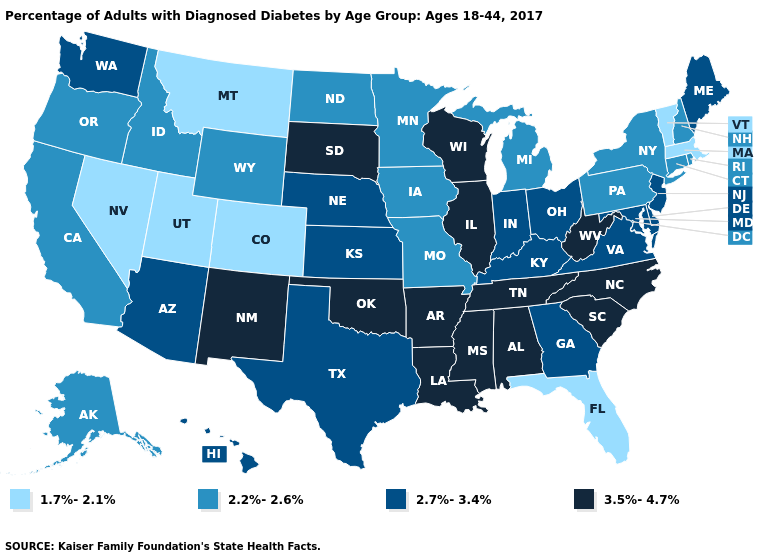What is the highest value in the USA?
Write a very short answer. 3.5%-4.7%. What is the value of Idaho?
Concise answer only. 2.2%-2.6%. What is the value of South Carolina?
Short answer required. 3.5%-4.7%. What is the highest value in the MidWest ?
Concise answer only. 3.5%-4.7%. Name the states that have a value in the range 1.7%-2.1%?
Keep it brief. Colorado, Florida, Massachusetts, Montana, Nevada, Utah, Vermont. What is the value of Wisconsin?
Be succinct. 3.5%-4.7%. What is the lowest value in the USA?
Be succinct. 1.7%-2.1%. Name the states that have a value in the range 2.7%-3.4%?
Give a very brief answer. Arizona, Delaware, Georgia, Hawaii, Indiana, Kansas, Kentucky, Maine, Maryland, Nebraska, New Jersey, Ohio, Texas, Virginia, Washington. Among the states that border West Virginia , which have the highest value?
Keep it brief. Kentucky, Maryland, Ohio, Virginia. Which states hav the highest value in the West?
Quick response, please. New Mexico. Among the states that border Rhode Island , which have the lowest value?
Give a very brief answer. Massachusetts. Does Alaska have the same value as Arkansas?
Quick response, please. No. How many symbols are there in the legend?
Give a very brief answer. 4. Name the states that have a value in the range 3.5%-4.7%?
Write a very short answer. Alabama, Arkansas, Illinois, Louisiana, Mississippi, New Mexico, North Carolina, Oklahoma, South Carolina, South Dakota, Tennessee, West Virginia, Wisconsin. Name the states that have a value in the range 2.2%-2.6%?
Write a very short answer. Alaska, California, Connecticut, Idaho, Iowa, Michigan, Minnesota, Missouri, New Hampshire, New York, North Dakota, Oregon, Pennsylvania, Rhode Island, Wyoming. 